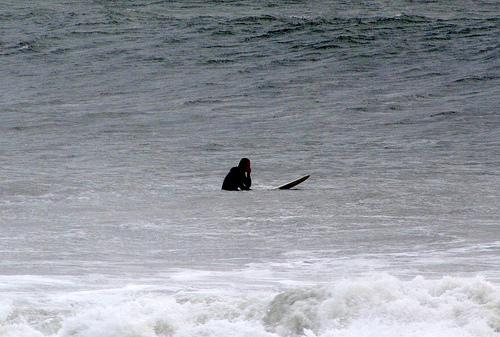Question: what is the person sitting on?
Choices:
A. Bicycle.
B. Couch.
C. Surfboard.
D. Motorcycle.
Answer with the letter. Answer: C Question: what sport is shown?
Choices:
A. Diving.
B. Surfing.
C. Rowing.
D. Jet Skiing.
Answer with the letter. Answer: B Question: what is surrounding the person?
Choices:
A. Grass.
B. Water.
C. Dirt.
D. Sand.
Answer with the letter. Answer: B 